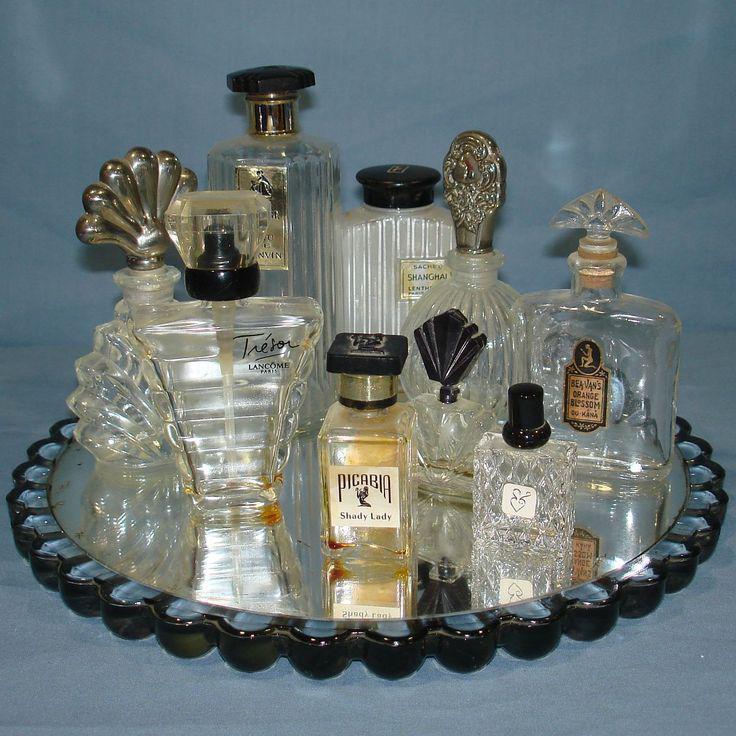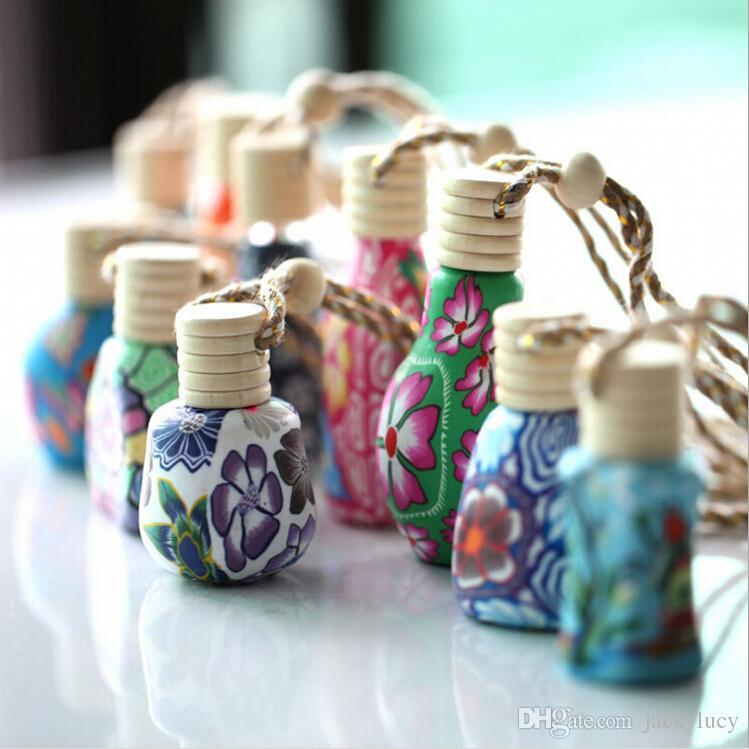The first image is the image on the left, the second image is the image on the right. Assess this claim about the two images: "At least one image is less than four fragrances.". Correct or not? Answer yes or no. No. The first image is the image on the left, the second image is the image on the right. Assess this claim about the two images: "An image includes fragrance bottles sitting on a round mirrored tray with scalloped edges.". Correct or not? Answer yes or no. Yes. 